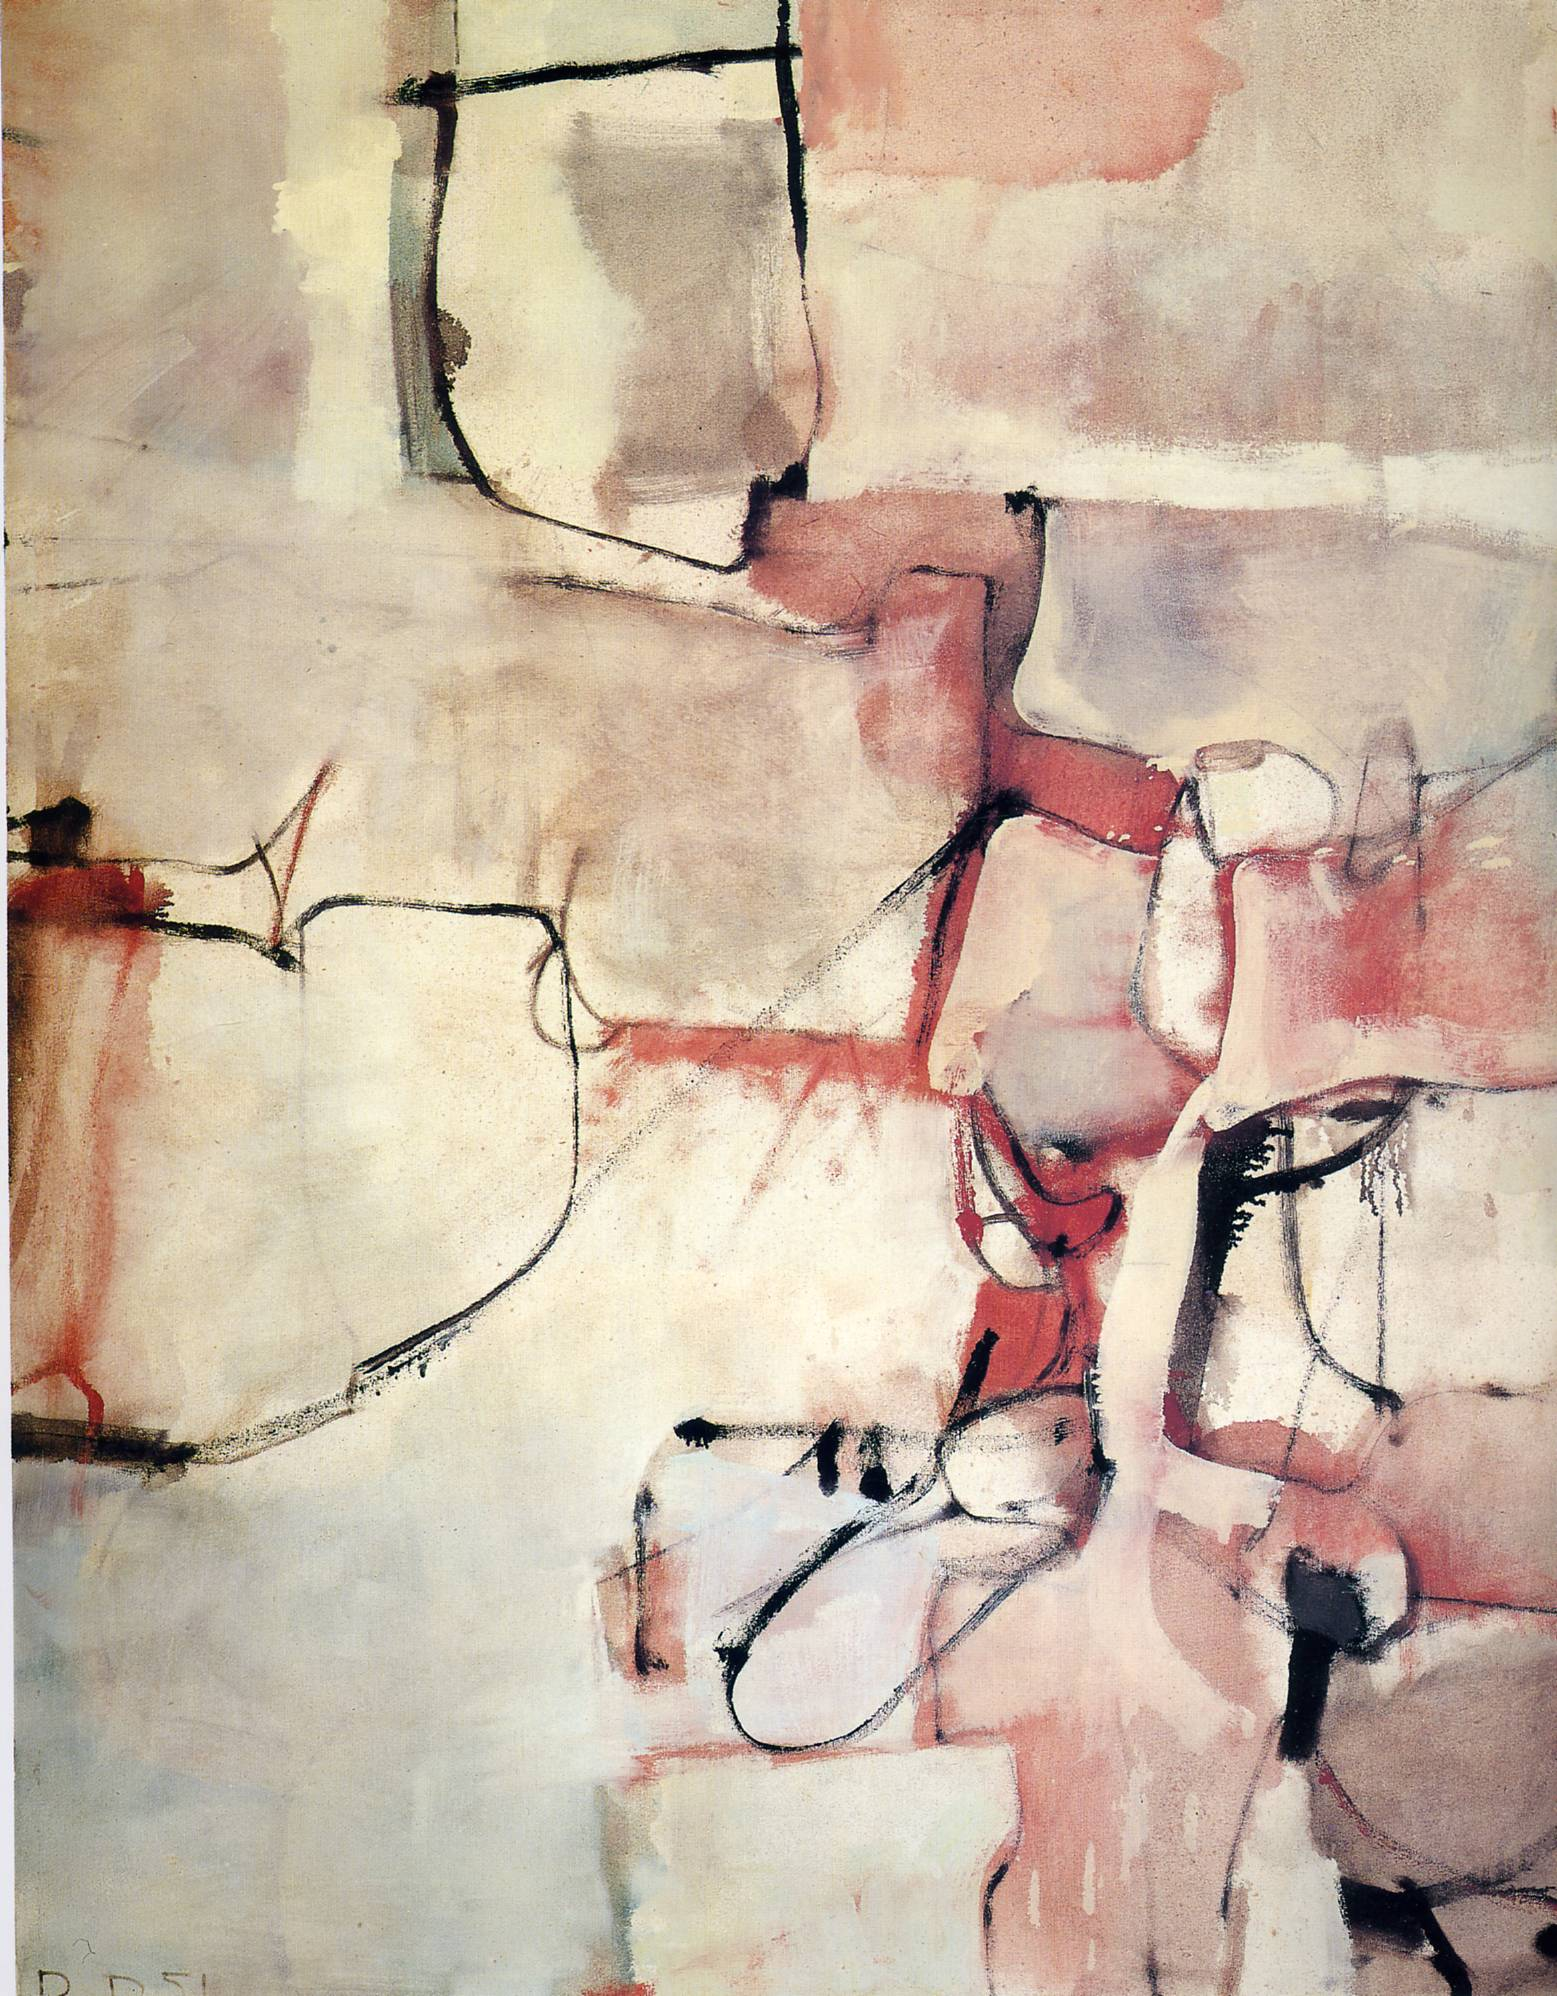How does the use of space and blank areas contribute to the overall effect of the painting? The strategic use of blank spaces in this painting plays a crucial role in balancing the visual weight of the colored and delineated areas. These empty spaces allow the viewer's eye to rest and provide a break from the intensity of the bold colors and shapes. Additionally, they emphasize the elements of form and line, making the colors seem more vibrant and the shapes more deliberate, thereby enhancing the painting's emotional impact and its abstract expression. 